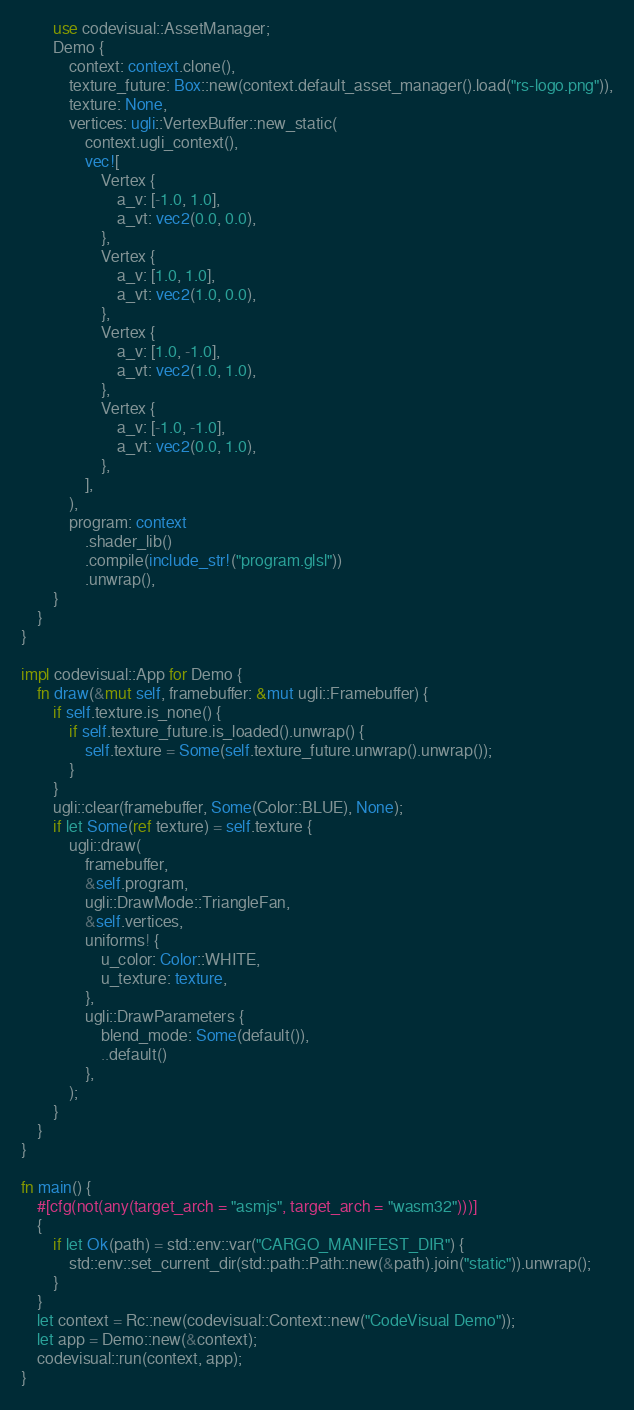Convert code to text. <code><loc_0><loc_0><loc_500><loc_500><_Rust_>        use codevisual::AssetManager;
        Demo {
            context: context.clone(),
            texture_future: Box::new(context.default_asset_manager().load("rs-logo.png")),
            texture: None,
            vertices: ugli::VertexBuffer::new_static(
                context.ugli_context(),
                vec![
                    Vertex {
                        a_v: [-1.0, 1.0],
                        a_vt: vec2(0.0, 0.0),
                    },
                    Vertex {
                        a_v: [1.0, 1.0],
                        a_vt: vec2(1.0, 0.0),
                    },
                    Vertex {
                        a_v: [1.0, -1.0],
                        a_vt: vec2(1.0, 1.0),
                    },
                    Vertex {
                        a_v: [-1.0, -1.0],
                        a_vt: vec2(0.0, 1.0),
                    },
                ],
            ),
            program: context
                .shader_lib()
                .compile(include_str!("program.glsl"))
                .unwrap(),
        }
    }
}

impl codevisual::App for Demo {
    fn draw(&mut self, framebuffer: &mut ugli::Framebuffer) {
        if self.texture.is_none() {
            if self.texture_future.is_loaded().unwrap() {
                self.texture = Some(self.texture_future.unwrap().unwrap());
            }
        }
        ugli::clear(framebuffer, Some(Color::BLUE), None);
        if let Some(ref texture) = self.texture {
            ugli::draw(
                framebuffer,
                &self.program,
                ugli::DrawMode::TriangleFan,
                &self.vertices,
                uniforms! {
                    u_color: Color::WHITE,
                    u_texture: texture,
                },
                ugli::DrawParameters {
                    blend_mode: Some(default()),
                    ..default()
                },
            );
        }
    }
}

fn main() {
    #[cfg(not(any(target_arch = "asmjs", target_arch = "wasm32")))]
    {
        if let Ok(path) = std::env::var("CARGO_MANIFEST_DIR") {
            std::env::set_current_dir(std::path::Path::new(&path).join("static")).unwrap();
        }
    }
    let context = Rc::new(codevisual::Context::new("CodeVisual Demo"));
    let app = Demo::new(&context);
    codevisual::run(context, app);
}
</code> 